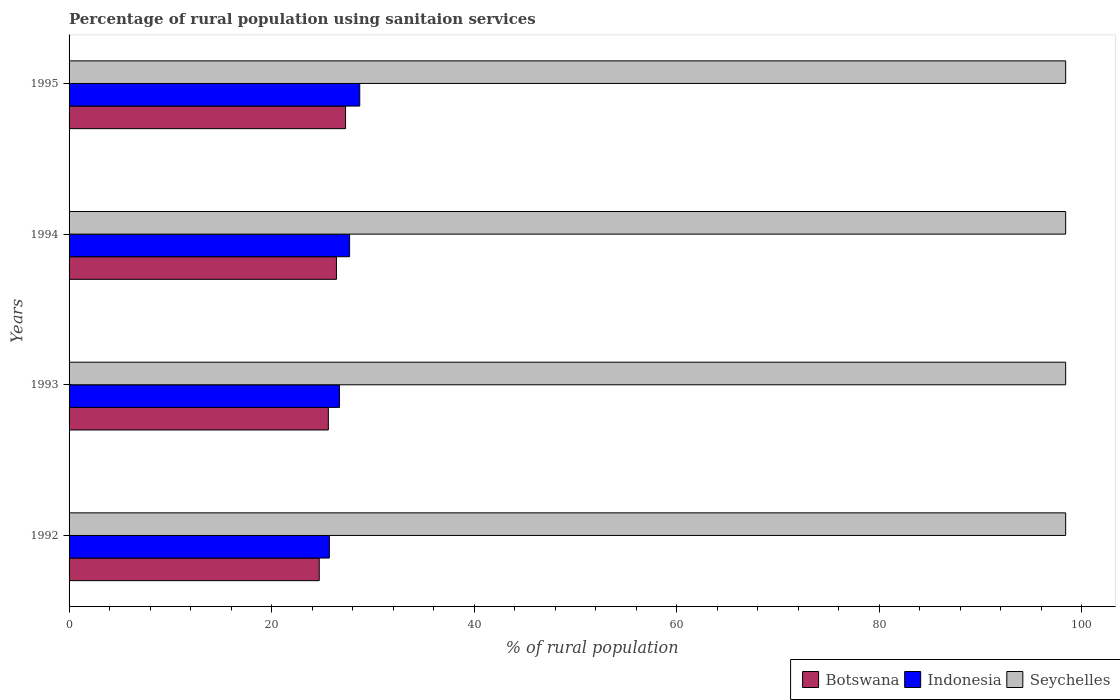Are the number of bars per tick equal to the number of legend labels?
Your answer should be compact. Yes. How many bars are there on the 1st tick from the top?
Your answer should be compact. 3. How many bars are there on the 1st tick from the bottom?
Your response must be concise. 3. What is the percentage of rural population using sanitaion services in Indonesia in 1994?
Provide a short and direct response. 27.7. Across all years, what is the maximum percentage of rural population using sanitaion services in Indonesia?
Make the answer very short. 28.7. Across all years, what is the minimum percentage of rural population using sanitaion services in Seychelles?
Give a very brief answer. 98.4. In which year was the percentage of rural population using sanitaion services in Indonesia maximum?
Ensure brevity in your answer.  1995. In which year was the percentage of rural population using sanitaion services in Indonesia minimum?
Your response must be concise. 1992. What is the total percentage of rural population using sanitaion services in Botswana in the graph?
Offer a very short reply. 104. What is the difference between the percentage of rural population using sanitaion services in Botswana in 1992 and that in 1993?
Give a very brief answer. -0.9. What is the difference between the percentage of rural population using sanitaion services in Seychelles in 1994 and the percentage of rural population using sanitaion services in Botswana in 1995?
Your response must be concise. 71.1. What is the average percentage of rural population using sanitaion services in Seychelles per year?
Your answer should be compact. 98.4. What is the ratio of the percentage of rural population using sanitaion services in Botswana in 1993 to that in 1995?
Offer a terse response. 0.94. What is the difference between the highest and the second highest percentage of rural population using sanitaion services in Seychelles?
Give a very brief answer. 0. What is the difference between the highest and the lowest percentage of rural population using sanitaion services in Seychelles?
Make the answer very short. 0. In how many years, is the percentage of rural population using sanitaion services in Botswana greater than the average percentage of rural population using sanitaion services in Botswana taken over all years?
Your answer should be very brief. 2. What does the 3rd bar from the top in 1992 represents?
Give a very brief answer. Botswana. What does the 3rd bar from the bottom in 1995 represents?
Ensure brevity in your answer.  Seychelles. Are all the bars in the graph horizontal?
Your answer should be very brief. Yes. How many years are there in the graph?
Your response must be concise. 4. What is the difference between two consecutive major ticks on the X-axis?
Keep it short and to the point. 20. Are the values on the major ticks of X-axis written in scientific E-notation?
Offer a very short reply. No. Does the graph contain grids?
Give a very brief answer. No. Where does the legend appear in the graph?
Ensure brevity in your answer.  Bottom right. How many legend labels are there?
Offer a very short reply. 3. How are the legend labels stacked?
Give a very brief answer. Horizontal. What is the title of the graph?
Provide a short and direct response. Percentage of rural population using sanitaion services. What is the label or title of the X-axis?
Your answer should be compact. % of rural population. What is the % of rural population of Botswana in 1992?
Provide a succinct answer. 24.7. What is the % of rural population of Indonesia in 1992?
Provide a short and direct response. 25.7. What is the % of rural population of Seychelles in 1992?
Offer a terse response. 98.4. What is the % of rural population of Botswana in 1993?
Offer a very short reply. 25.6. What is the % of rural population in Indonesia in 1993?
Keep it short and to the point. 26.7. What is the % of rural population of Seychelles in 1993?
Your response must be concise. 98.4. What is the % of rural population of Botswana in 1994?
Ensure brevity in your answer.  26.4. What is the % of rural population in Indonesia in 1994?
Provide a short and direct response. 27.7. What is the % of rural population in Seychelles in 1994?
Your response must be concise. 98.4. What is the % of rural population in Botswana in 1995?
Give a very brief answer. 27.3. What is the % of rural population in Indonesia in 1995?
Ensure brevity in your answer.  28.7. What is the % of rural population in Seychelles in 1995?
Offer a terse response. 98.4. Across all years, what is the maximum % of rural population in Botswana?
Your answer should be compact. 27.3. Across all years, what is the maximum % of rural population of Indonesia?
Your answer should be compact. 28.7. Across all years, what is the maximum % of rural population of Seychelles?
Provide a short and direct response. 98.4. Across all years, what is the minimum % of rural population of Botswana?
Offer a terse response. 24.7. Across all years, what is the minimum % of rural population in Indonesia?
Keep it short and to the point. 25.7. Across all years, what is the minimum % of rural population of Seychelles?
Give a very brief answer. 98.4. What is the total % of rural population in Botswana in the graph?
Provide a short and direct response. 104. What is the total % of rural population in Indonesia in the graph?
Keep it short and to the point. 108.8. What is the total % of rural population of Seychelles in the graph?
Offer a terse response. 393.6. What is the difference between the % of rural population in Indonesia in 1992 and that in 1993?
Provide a short and direct response. -1. What is the difference between the % of rural population in Seychelles in 1992 and that in 1993?
Offer a terse response. 0. What is the difference between the % of rural population of Indonesia in 1992 and that in 1994?
Offer a very short reply. -2. What is the difference between the % of rural population in Seychelles in 1992 and that in 1994?
Your response must be concise. 0. What is the difference between the % of rural population in Botswana in 1992 and that in 1995?
Provide a short and direct response. -2.6. What is the difference between the % of rural population of Indonesia in 1992 and that in 1995?
Your answer should be very brief. -3. What is the difference between the % of rural population in Seychelles in 1992 and that in 1995?
Ensure brevity in your answer.  0. What is the difference between the % of rural population in Indonesia in 1993 and that in 1994?
Ensure brevity in your answer.  -1. What is the difference between the % of rural population in Seychelles in 1993 and that in 1994?
Ensure brevity in your answer.  0. What is the difference between the % of rural population of Seychelles in 1993 and that in 1995?
Provide a short and direct response. 0. What is the difference between the % of rural population of Indonesia in 1994 and that in 1995?
Offer a very short reply. -1. What is the difference between the % of rural population in Seychelles in 1994 and that in 1995?
Offer a terse response. 0. What is the difference between the % of rural population in Botswana in 1992 and the % of rural population in Seychelles in 1993?
Your response must be concise. -73.7. What is the difference between the % of rural population of Indonesia in 1992 and the % of rural population of Seychelles in 1993?
Keep it short and to the point. -72.7. What is the difference between the % of rural population of Botswana in 1992 and the % of rural population of Seychelles in 1994?
Keep it short and to the point. -73.7. What is the difference between the % of rural population of Indonesia in 1992 and the % of rural population of Seychelles in 1994?
Offer a terse response. -72.7. What is the difference between the % of rural population in Botswana in 1992 and the % of rural population in Seychelles in 1995?
Your answer should be very brief. -73.7. What is the difference between the % of rural population in Indonesia in 1992 and the % of rural population in Seychelles in 1995?
Give a very brief answer. -72.7. What is the difference between the % of rural population of Botswana in 1993 and the % of rural population of Indonesia in 1994?
Your answer should be compact. -2.1. What is the difference between the % of rural population of Botswana in 1993 and the % of rural population of Seychelles in 1994?
Offer a terse response. -72.8. What is the difference between the % of rural population in Indonesia in 1993 and the % of rural population in Seychelles in 1994?
Give a very brief answer. -71.7. What is the difference between the % of rural population in Botswana in 1993 and the % of rural population in Indonesia in 1995?
Your answer should be compact. -3.1. What is the difference between the % of rural population of Botswana in 1993 and the % of rural population of Seychelles in 1995?
Make the answer very short. -72.8. What is the difference between the % of rural population in Indonesia in 1993 and the % of rural population in Seychelles in 1995?
Ensure brevity in your answer.  -71.7. What is the difference between the % of rural population in Botswana in 1994 and the % of rural population in Indonesia in 1995?
Your answer should be very brief. -2.3. What is the difference between the % of rural population in Botswana in 1994 and the % of rural population in Seychelles in 1995?
Your response must be concise. -72. What is the difference between the % of rural population in Indonesia in 1994 and the % of rural population in Seychelles in 1995?
Offer a very short reply. -70.7. What is the average % of rural population in Indonesia per year?
Provide a short and direct response. 27.2. What is the average % of rural population in Seychelles per year?
Offer a very short reply. 98.4. In the year 1992, what is the difference between the % of rural population in Botswana and % of rural population in Seychelles?
Offer a terse response. -73.7. In the year 1992, what is the difference between the % of rural population of Indonesia and % of rural population of Seychelles?
Give a very brief answer. -72.7. In the year 1993, what is the difference between the % of rural population of Botswana and % of rural population of Seychelles?
Your answer should be compact. -72.8. In the year 1993, what is the difference between the % of rural population of Indonesia and % of rural population of Seychelles?
Your response must be concise. -71.7. In the year 1994, what is the difference between the % of rural population in Botswana and % of rural population in Indonesia?
Keep it short and to the point. -1.3. In the year 1994, what is the difference between the % of rural population of Botswana and % of rural population of Seychelles?
Provide a succinct answer. -72. In the year 1994, what is the difference between the % of rural population of Indonesia and % of rural population of Seychelles?
Your answer should be compact. -70.7. In the year 1995, what is the difference between the % of rural population in Botswana and % of rural population in Seychelles?
Give a very brief answer. -71.1. In the year 1995, what is the difference between the % of rural population in Indonesia and % of rural population in Seychelles?
Keep it short and to the point. -69.7. What is the ratio of the % of rural population of Botswana in 1992 to that in 1993?
Provide a succinct answer. 0.96. What is the ratio of the % of rural population in Indonesia in 1992 to that in 1993?
Your response must be concise. 0.96. What is the ratio of the % of rural population in Seychelles in 1992 to that in 1993?
Provide a short and direct response. 1. What is the ratio of the % of rural population of Botswana in 1992 to that in 1994?
Your response must be concise. 0.94. What is the ratio of the % of rural population in Indonesia in 1992 to that in 1994?
Ensure brevity in your answer.  0.93. What is the ratio of the % of rural population in Seychelles in 1992 to that in 1994?
Your response must be concise. 1. What is the ratio of the % of rural population in Botswana in 1992 to that in 1995?
Ensure brevity in your answer.  0.9. What is the ratio of the % of rural population in Indonesia in 1992 to that in 1995?
Offer a very short reply. 0.9. What is the ratio of the % of rural population in Seychelles in 1992 to that in 1995?
Your response must be concise. 1. What is the ratio of the % of rural population of Botswana in 1993 to that in 1994?
Ensure brevity in your answer.  0.97. What is the ratio of the % of rural population of Indonesia in 1993 to that in 1994?
Your response must be concise. 0.96. What is the ratio of the % of rural population of Botswana in 1993 to that in 1995?
Provide a succinct answer. 0.94. What is the ratio of the % of rural population in Indonesia in 1993 to that in 1995?
Ensure brevity in your answer.  0.93. What is the ratio of the % of rural population of Indonesia in 1994 to that in 1995?
Your answer should be compact. 0.97. What is the difference between the highest and the lowest % of rural population of Seychelles?
Your answer should be very brief. 0. 